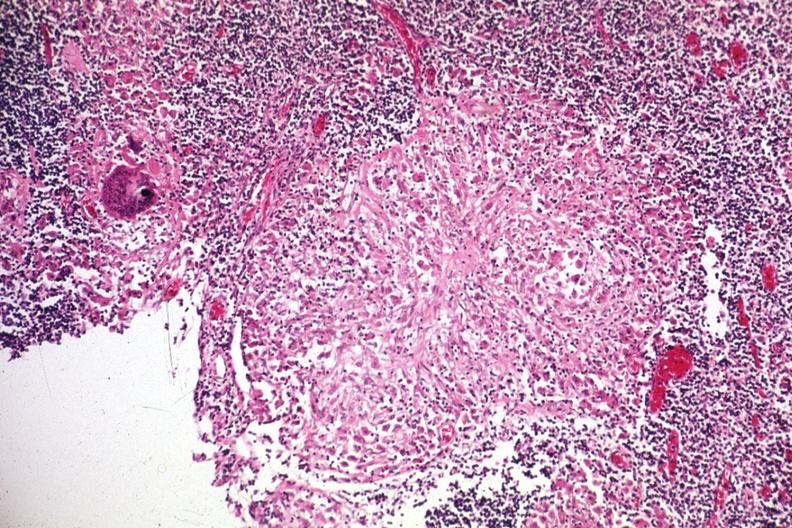does this image show granuloma?
Answer the question using a single word or phrase. Yes 